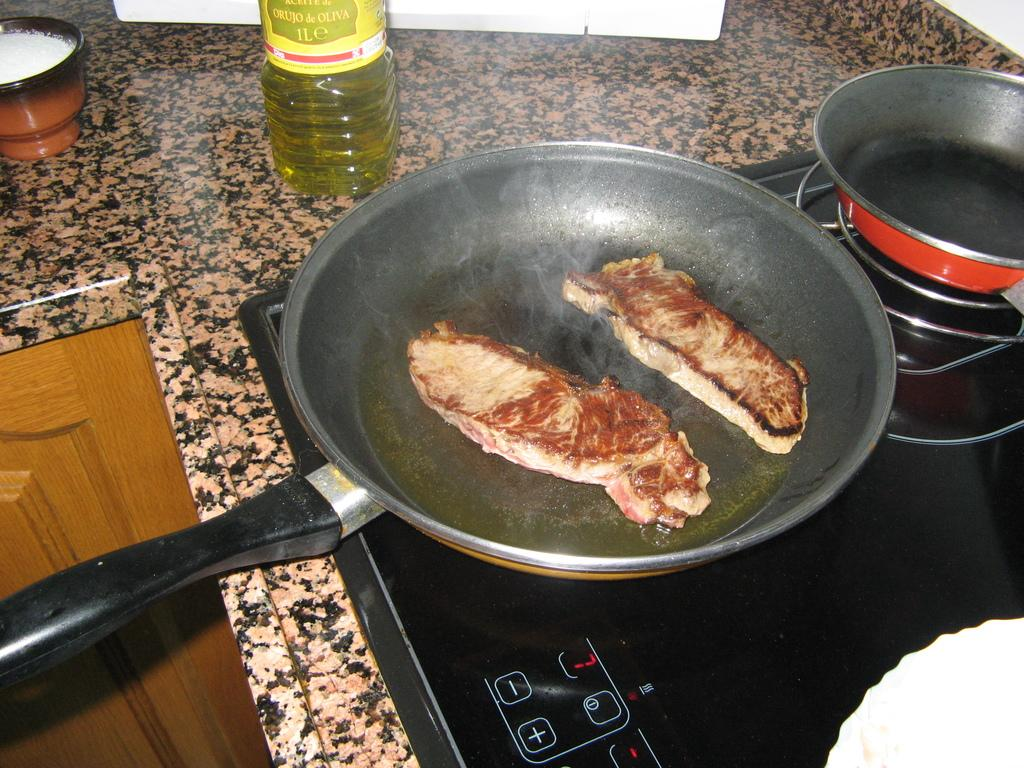What type of appliance is present in the image? There is an oven in the image. What is placed on top of the oven? There is a plate on the oven. What is on the plate? There is a food item on the plate. What can be seen on the table in the image? There are bottles on the table. What type of airplane is visible in the image? There is no airplane present in the image; it features an oven, a plate, a food item, and bottles on a table. What type of operation is being performed in the image? There is no operation being performed in the image; it shows an oven, a plate, a food item, and bottles on a table. 